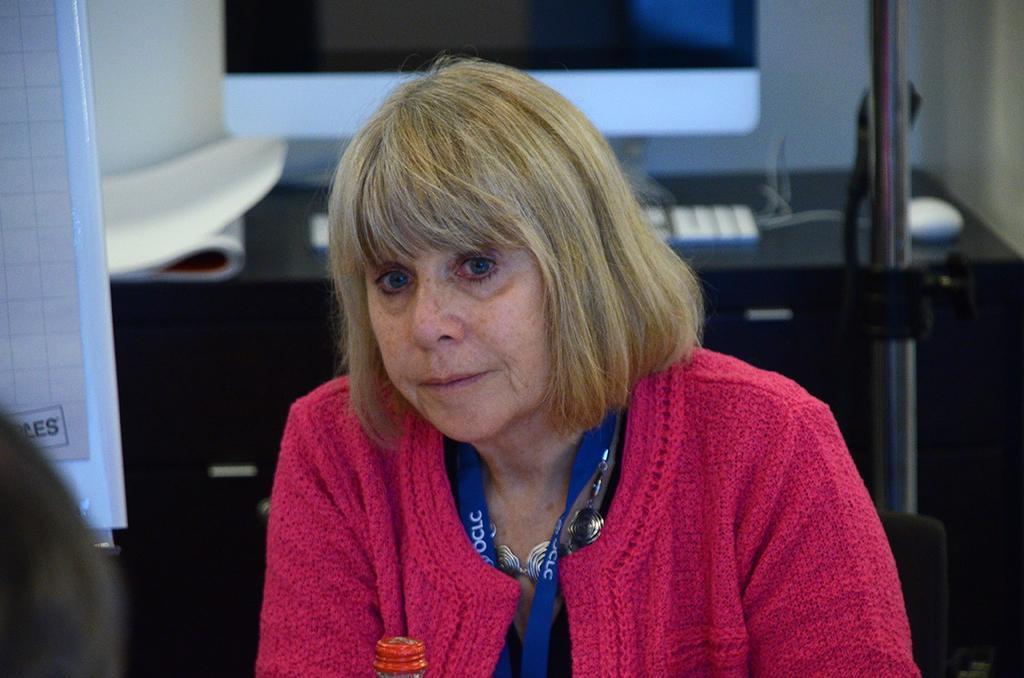How would you summarize this image in a sentence or two? This image consists of a woman wearing a pink sweater. In front of her, there is a bottle. On the left, we can see a board. In the background, we can see a desk. On which, we can see a computer. On the right, there is a rod. 